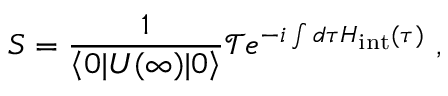<formula> <loc_0><loc_0><loc_500><loc_500>S = { \frac { 1 } { \left \langle 0 | U ( \infty ) | 0 \right \rangle } } { \mathcal { T } } e ^ { - i \int { d \tau H _ { i n t } ( \tau ) } } ,</formula> 